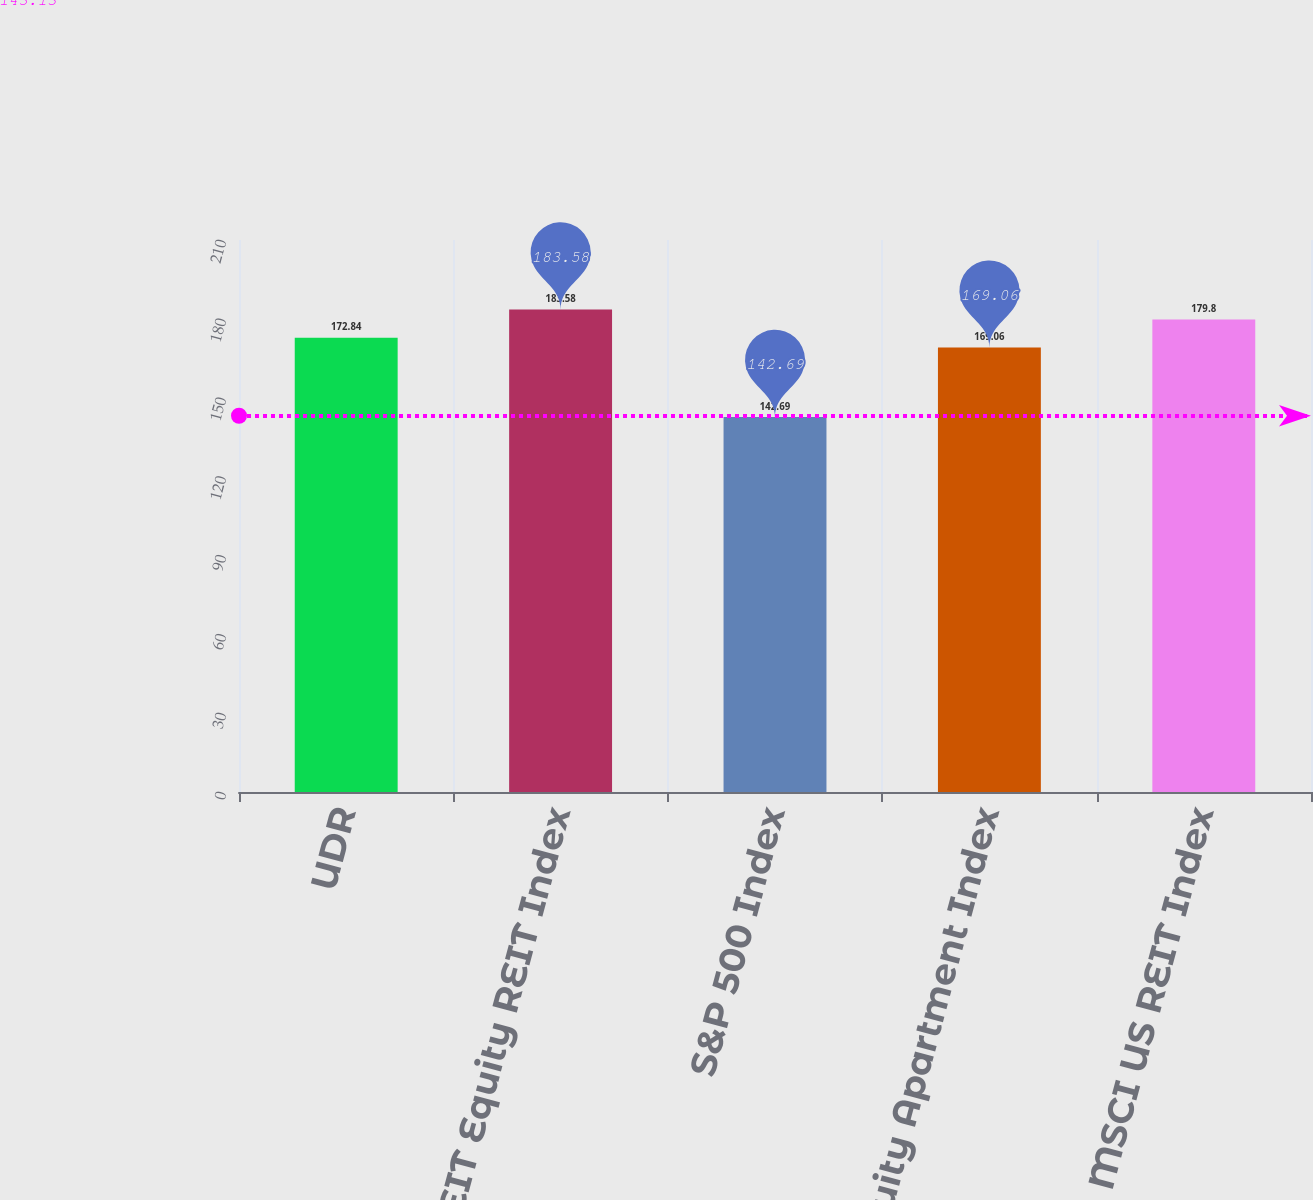<chart> <loc_0><loc_0><loc_500><loc_500><bar_chart><fcel>UDR<fcel>NAREIT Equity REIT Index<fcel>S&P 500 Index<fcel>NAREIT Equity Apartment Index<fcel>MSCI US REIT Index<nl><fcel>172.84<fcel>183.58<fcel>142.69<fcel>169.06<fcel>179.8<nl></chart> 